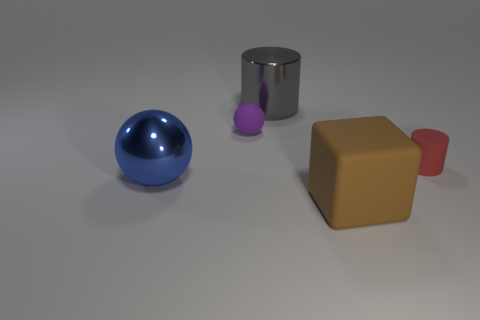Add 5 tiny things. How many objects exist? 10 Subtract all cylinders. How many objects are left? 3 Subtract all metallic cubes. Subtract all large matte blocks. How many objects are left? 4 Add 2 large gray shiny objects. How many large gray shiny objects are left? 3 Add 2 tiny cyan cylinders. How many tiny cyan cylinders exist? 2 Subtract 0 gray blocks. How many objects are left? 5 